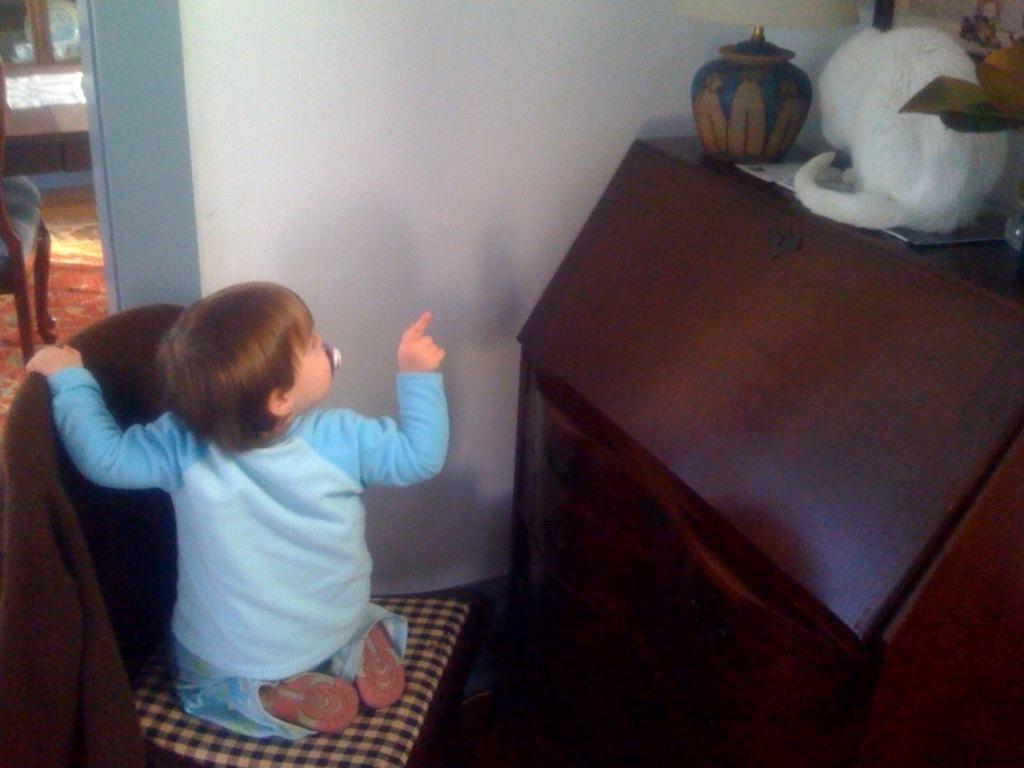Please provide a concise description of this image. In this picture on the top right there is a desk, on the desk there is a cat and their lamp. On the left there is a chair, on the chair there is a kid. On the top left there is a closet and chair. In the center of the background there is a wall. 